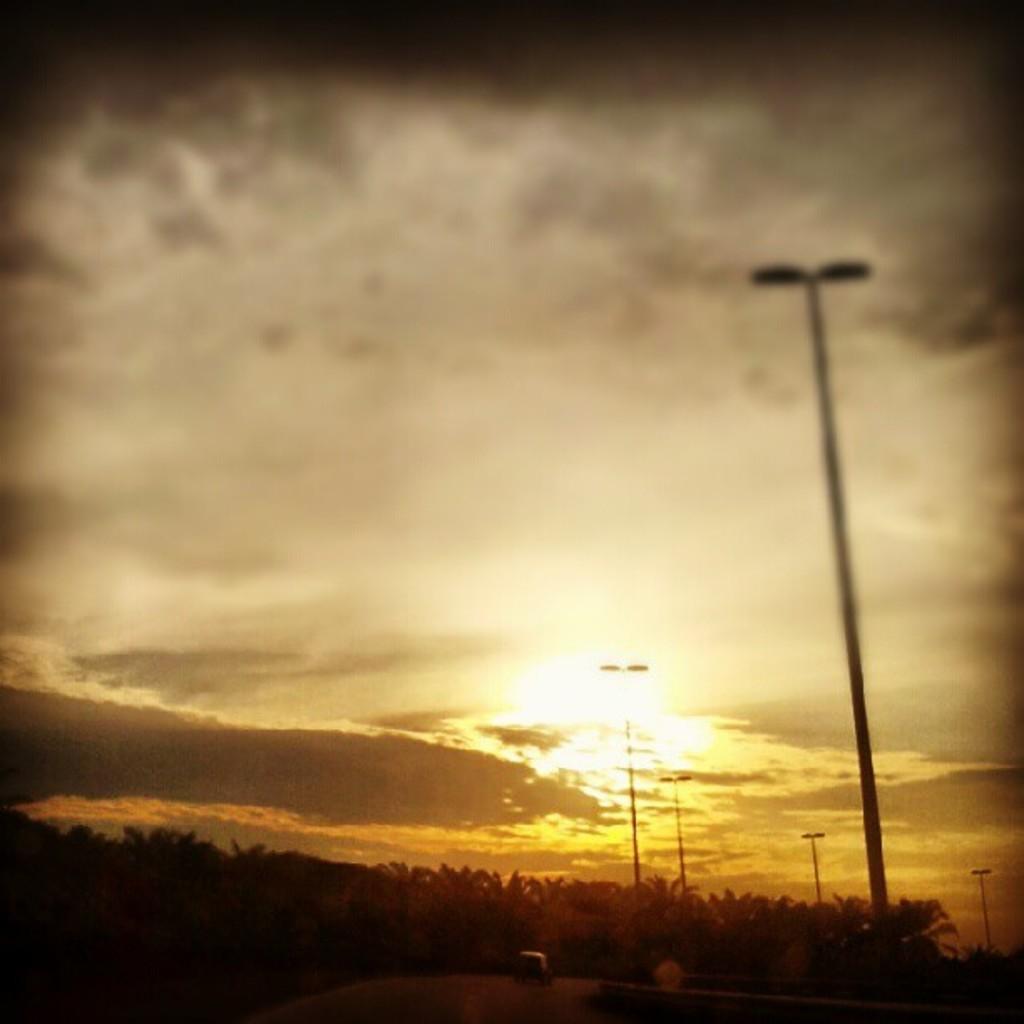Describe this image in one or two sentences. In this image there is the sky. To the right there are street light poles. At the bottom there are trees. 